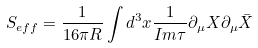<formula> <loc_0><loc_0><loc_500><loc_500>S _ { e f f } = \frac { 1 } { 1 6 \pi R } \int d ^ { 3 } x \frac { 1 } { I m \tau } \partial _ { \mu } X \partial _ { \mu } \bar { X }</formula> 